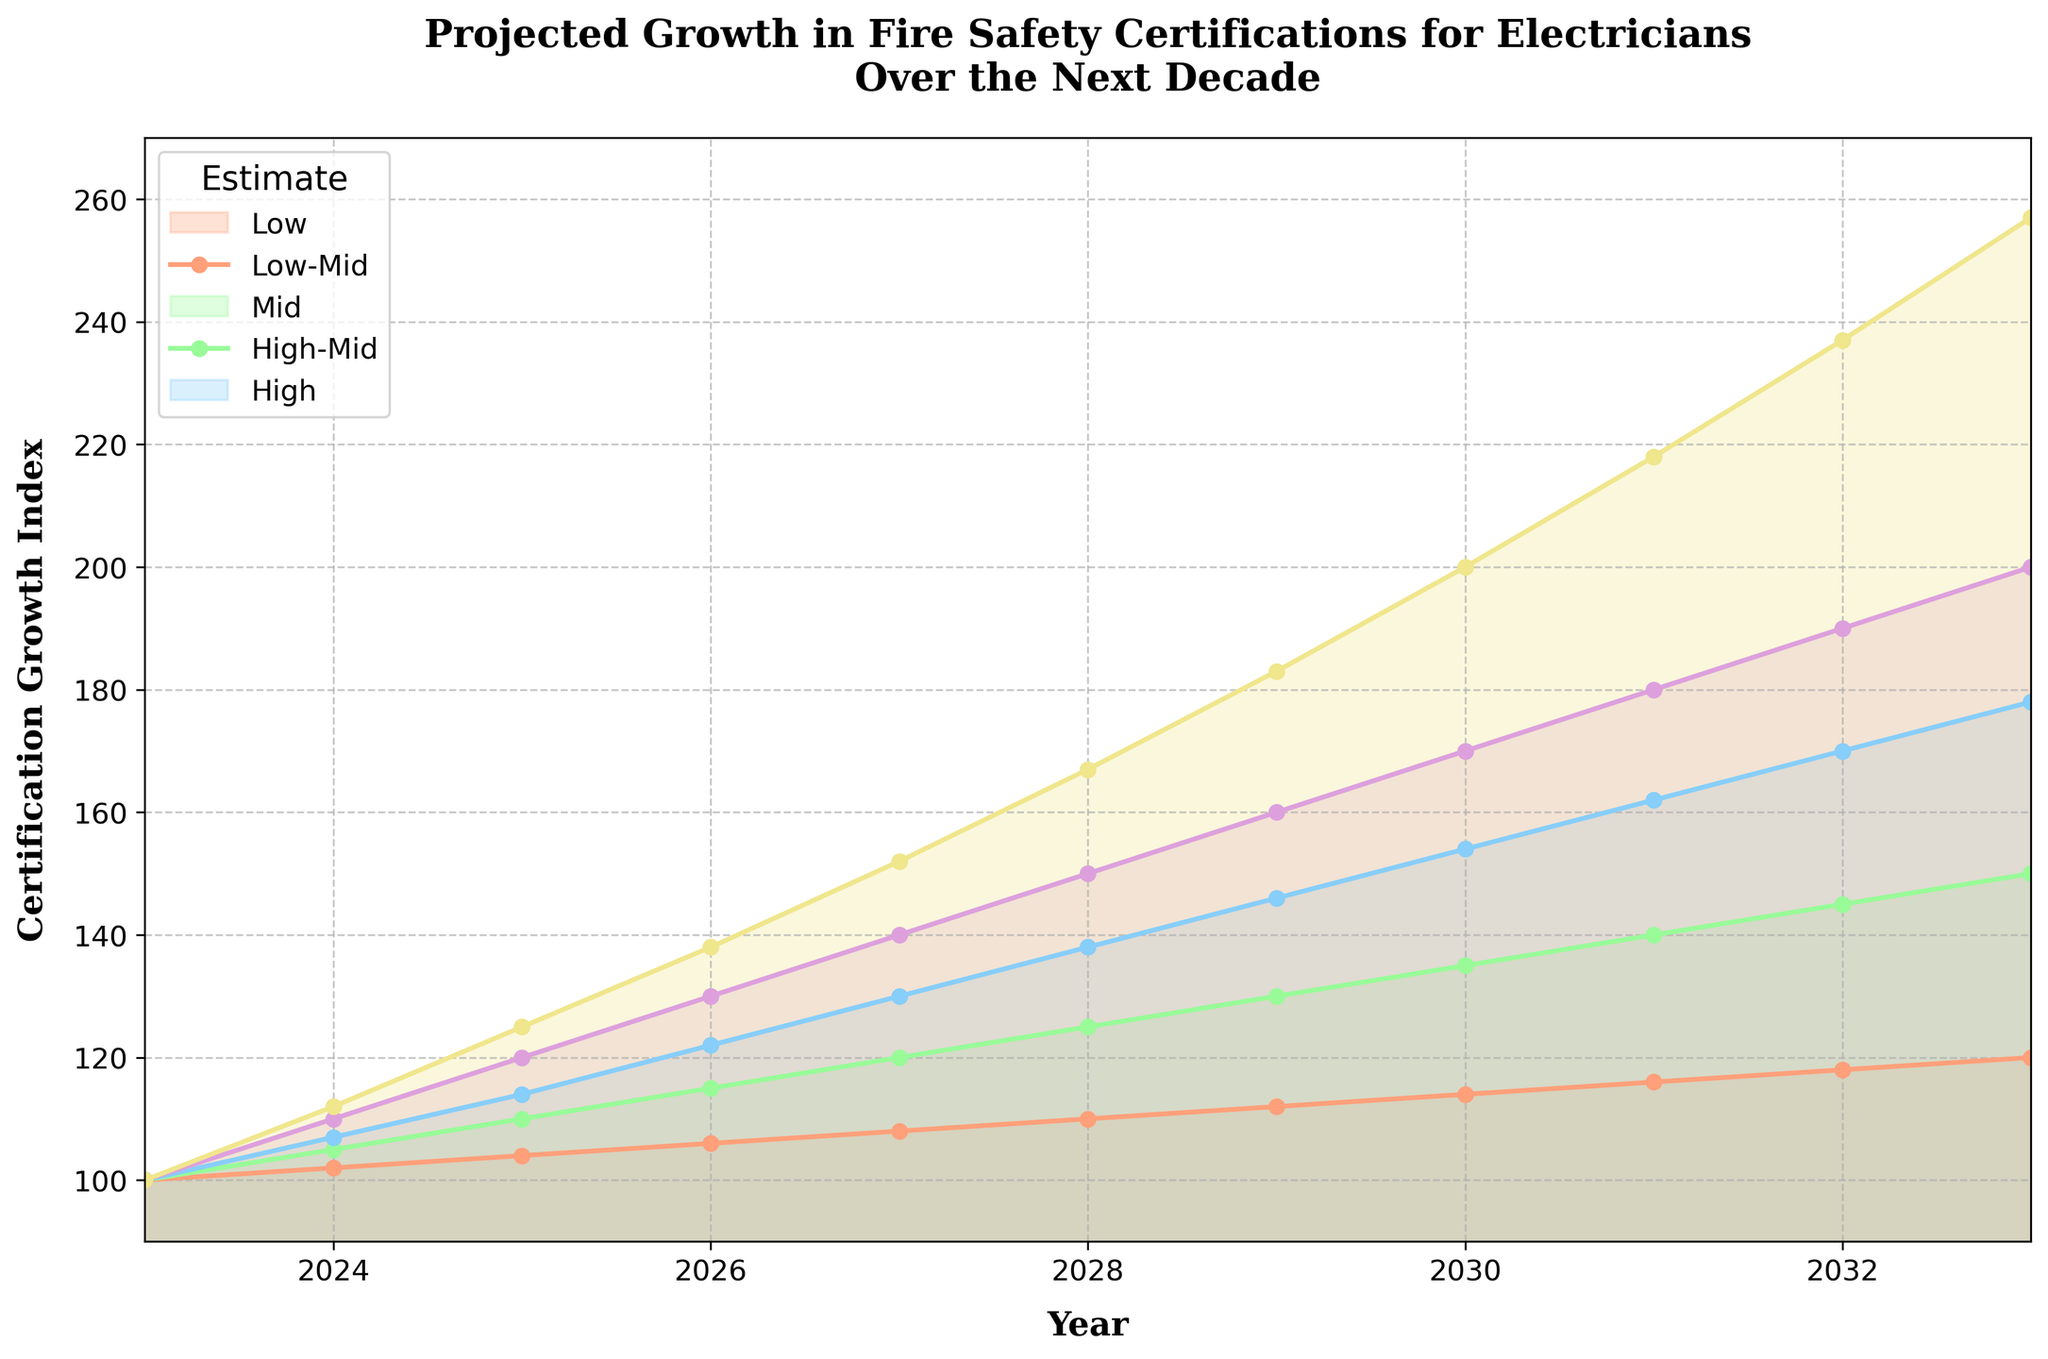What's the title of the chart? The title of the chart is located at the top and reads "Projected Growth in Fire Safety Certifications for Electricians Over the Next Decade".
Answer: Projected Growth in Fire Safety Certifications for Electricians Over the Next Decade How many years are projected in the chart? The x-axis of the chart shows years starting from 2023 to 2033, which totals 11 years.
Answer: 11 What's the estimated certification growth index in 2030 for the mid estimate? From the line marked "Mid Estimate" and corresponding point in 2030, we see the index value is 154.
Answer: 154 In which year is the high estimate first greater than 150? Locate the high estimate line (topmost) and identify the first year where it crosses above 150. This occurs in 2027.
Answer: 2027 What is the difference between the high and low estimates in 2028? For the year 2028, the high estimate is 167 and the low estimate is 110. The difference is 167 - 110 = 57.
Answer: 57 By how much does the mid estimate certification growth index increase from 2024 to 2026? The mid estimate in 2024 is 107 and in 2026 it is 122. The increase is 122 - 107 = 15.
Answer: 15 Which estimate group showed the maximum growth from 2023 to 2033? Compare the growth from 2023 to 2033 for all estimate lines. The high estimate showed the maximum growth, from 100 to 257.
Answer: High Among the estimates, which has the smallest error margin in 2026? Error margin is the difference between high estimate and low estimate. For 2026, verify and compare error margin: high is 138, low is 106, so margin is 32. It is the smallest amongst other years.
Answer: 32 What's the average value of the low-mid estimates from 2028 to 2030? Add low-mid estimates for 2028, 2029, 2030: 125 + 130 + 135 = 390, and there are 3 years, so average = 390 / 3 = 130.
Answer: 130 